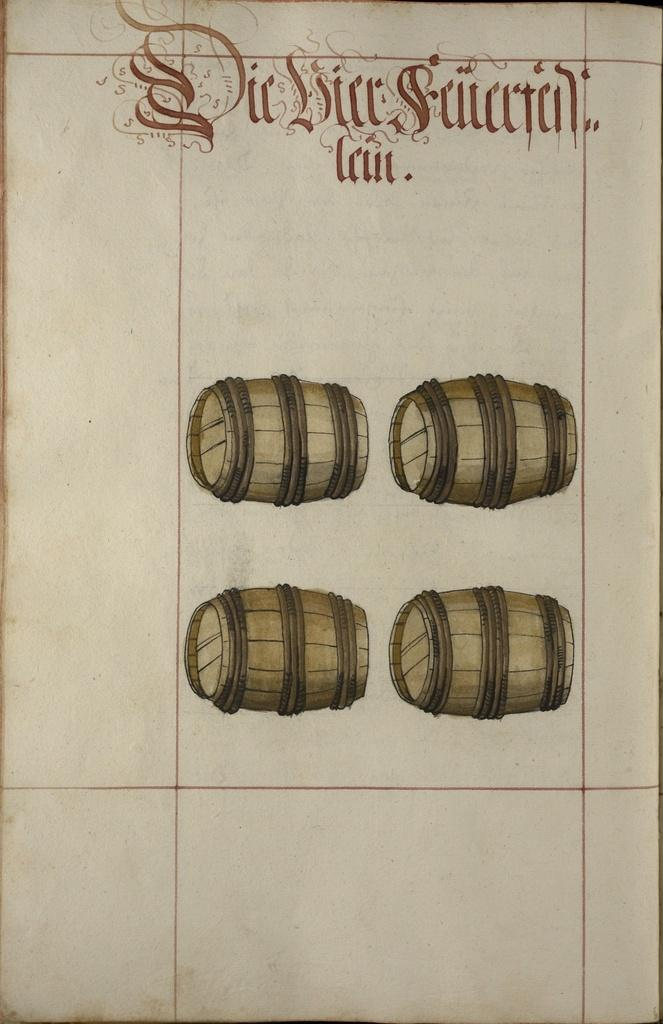What is the main subject of the image? The main subject of the image is a paper. What is depicted in the center of the paper? There are paintings of drums in the center of the paper. Is there any text present on the paper? Yes, there is text at the top of the paper. What type of quill is being used to write the text on the paper? There is no quill visible in the image, and it is not mentioned in the provided facts. What company is responsible for producing the paper in the image? The provided facts do not mention any company or brand associated with the paper. 